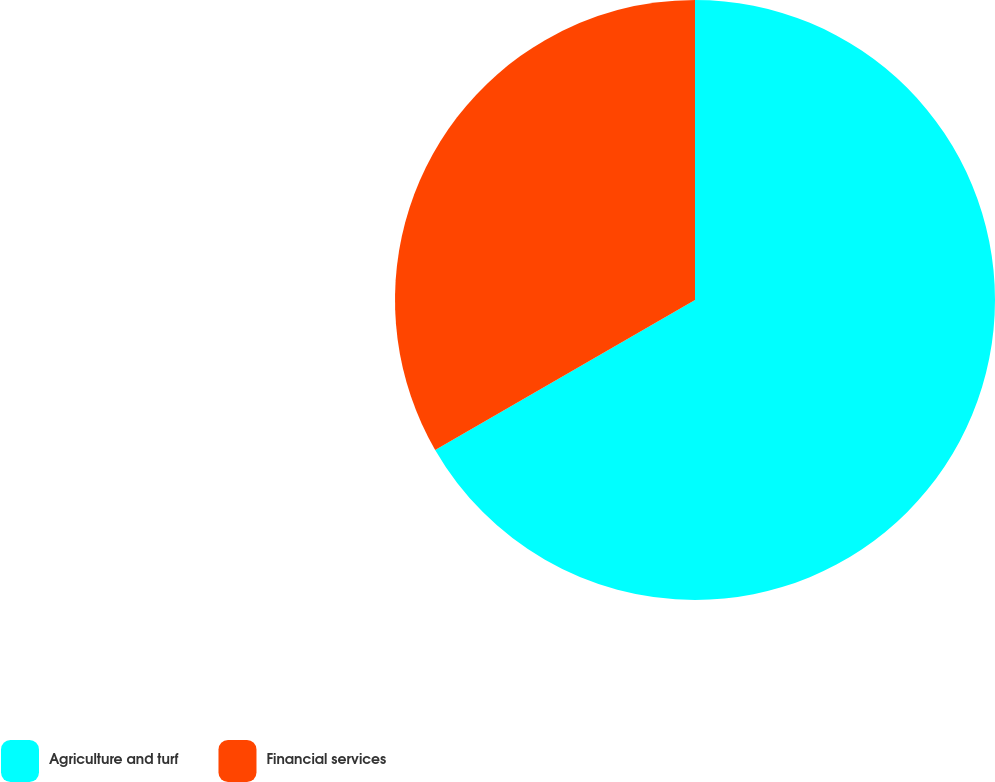Convert chart to OTSL. <chart><loc_0><loc_0><loc_500><loc_500><pie_chart><fcel>Agriculture and turf<fcel>Financial services<nl><fcel>66.67%<fcel>33.33%<nl></chart> 